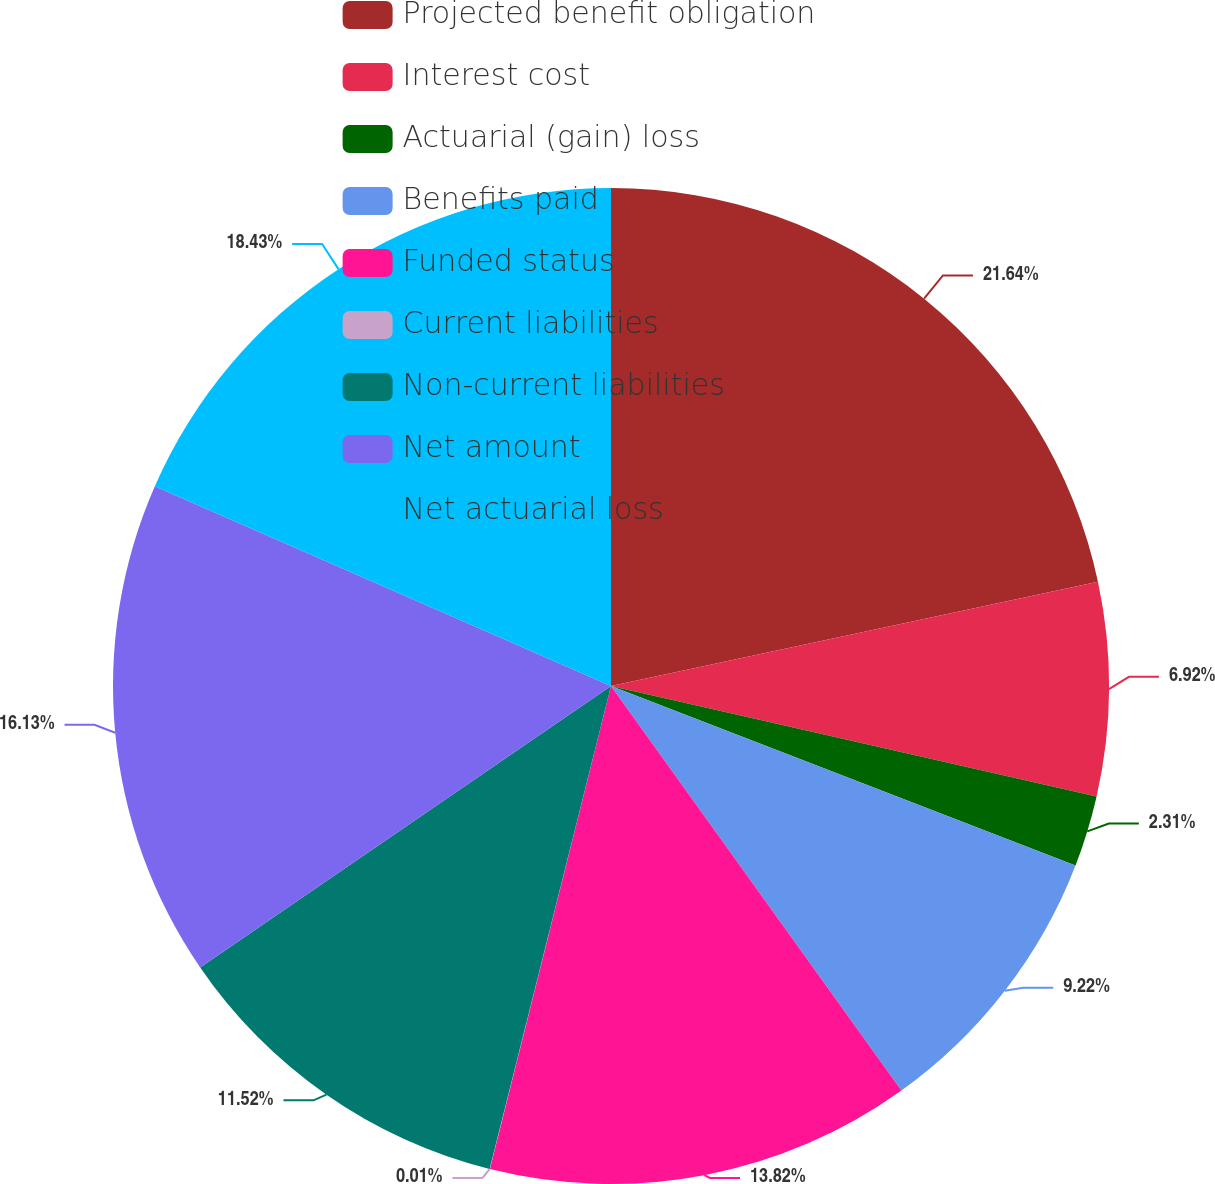Convert chart to OTSL. <chart><loc_0><loc_0><loc_500><loc_500><pie_chart><fcel>Projected benefit obligation<fcel>Interest cost<fcel>Actuarial (gain) loss<fcel>Benefits paid<fcel>Funded status<fcel>Current liabilities<fcel>Non-current liabilities<fcel>Net amount<fcel>Net actuarial loss<nl><fcel>21.64%<fcel>6.92%<fcel>2.31%<fcel>9.22%<fcel>13.82%<fcel>0.01%<fcel>11.52%<fcel>16.13%<fcel>18.43%<nl></chart> 